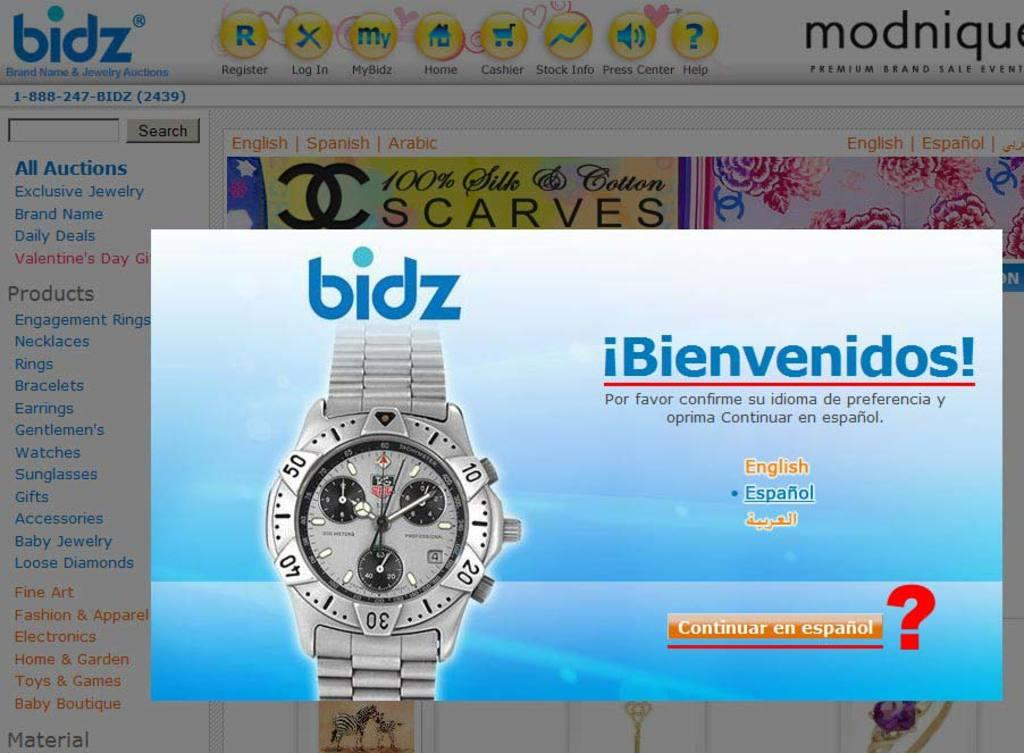<image>
Present a compact description of the photo's key features. An auction website and one must choose their language to proceed further. 